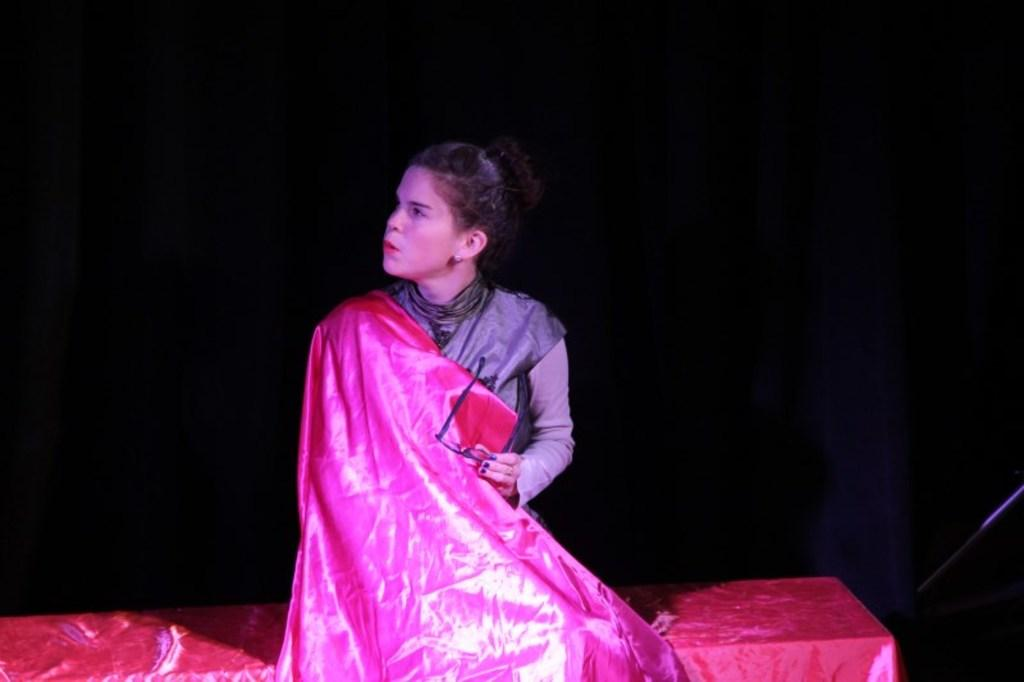Who is the main subject in the image? There is a woman in the image. What is the woman wearing? The woman is wearing a black dress. What is the woman doing in the image? The woman is sitting on a bench. What can be observed about the background of the image? The background of the image is dark. What type of bone can be seen in the woman's hand in the image? There is no bone present in the woman's hand or in the image. 